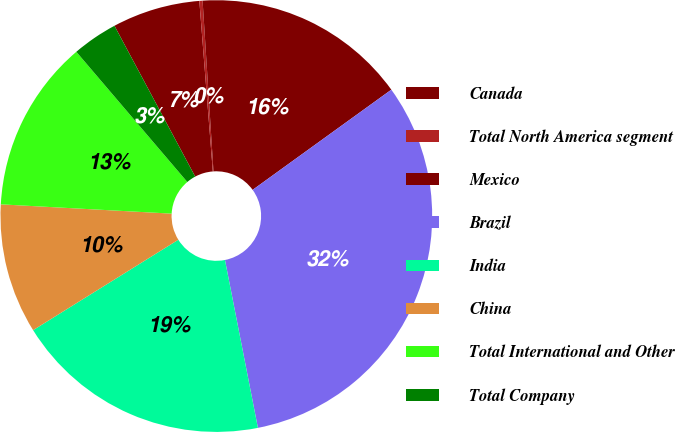Convert chart to OTSL. <chart><loc_0><loc_0><loc_500><loc_500><pie_chart><fcel>Canada<fcel>Total North America segment<fcel>Mexico<fcel>Brazil<fcel>India<fcel>China<fcel>Total International and Other<fcel>Total Company<nl><fcel>6.57%<fcel>0.24%<fcel>16.06%<fcel>31.87%<fcel>19.22%<fcel>9.73%<fcel>12.9%<fcel>3.41%<nl></chart> 